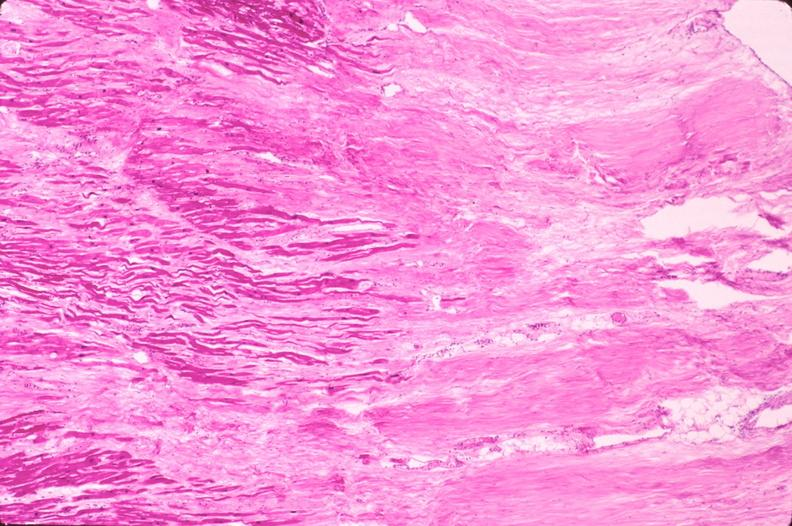s cardiovascular present?
Answer the question using a single word or phrase. Yes 